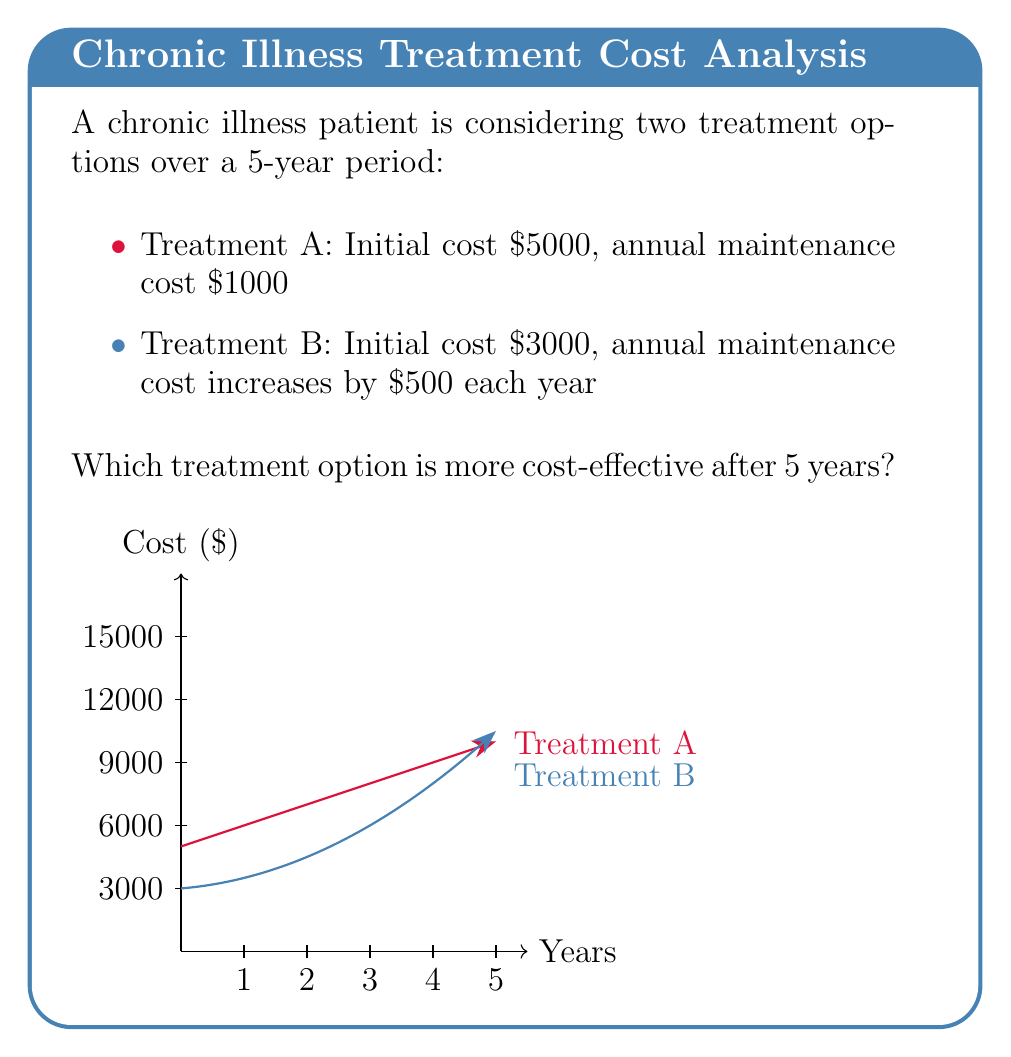Can you answer this question? Let's analyze the cost of each treatment over 5 years:

1. Treatment A:
   - Initial cost: $5000
   - Annual maintenance: $1000 x 5 years = $5000
   - Total cost: $5000 + $5000 = $10000

2. Treatment B:
   - Initial cost: $3000
   - Annual maintenance:
     Year 1: $500
     Year 2: $1000
     Year 3: $1500
     Year 4: $2000
     Year 5: $2500
   - Total maintenance: $500 + $1000 + $1500 + $2000 + $2500 = $7500
   - Total cost: $3000 + $7500 = $10500

We can express the total cost of Treatment B using the arithmetic sequence sum formula:

$$ \text{Total Cost B} = 3000 + 500 \cdot \frac{n(n+1)}{2} $$

Where $n$ is the number of years. For 5 years:

$$ \text{Total Cost B} = 3000 + 500 \cdot \frac{5(5+1)}{2} = 3000 + 7500 = 10500 $$

Comparing the two:
Treatment A: $10000
Treatment B: $10500

Therefore, Treatment A is more cost-effective after 5 years, saving $500 compared to Treatment B.
Answer: Treatment A ($10000 vs $10500) 